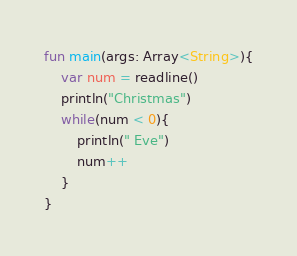<code> <loc_0><loc_0><loc_500><loc_500><_Kotlin_>fun main(args: Array<String>){
    var num = readline()
    println("Christmas")
    while(num < 0){
        println(" Eve")
        num++
    }
}</code> 